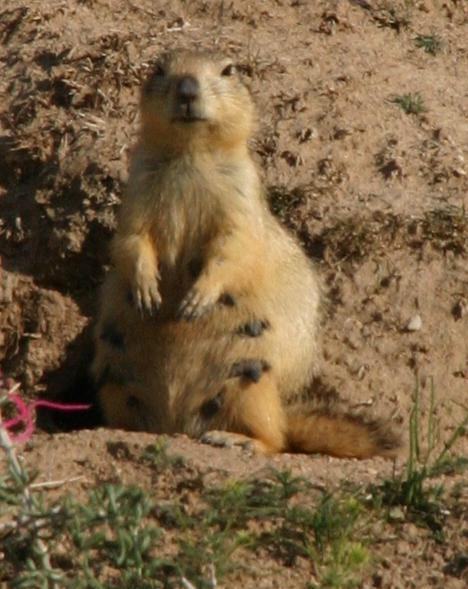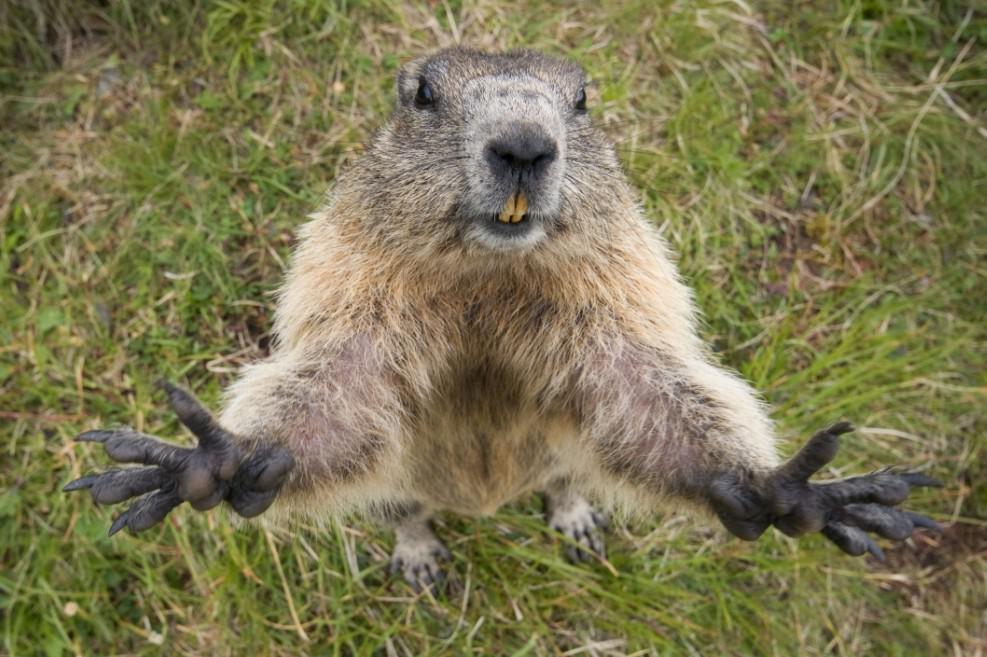The first image is the image on the left, the second image is the image on the right. Analyze the images presented: Is the assertion "In at least one of the images, there is just one marmot" valid? Answer yes or no. Yes. The first image is the image on the left, the second image is the image on the right. Assess this claim about the two images: "At least one image has exactly one animal.". Correct or not? Answer yes or no. Yes. 